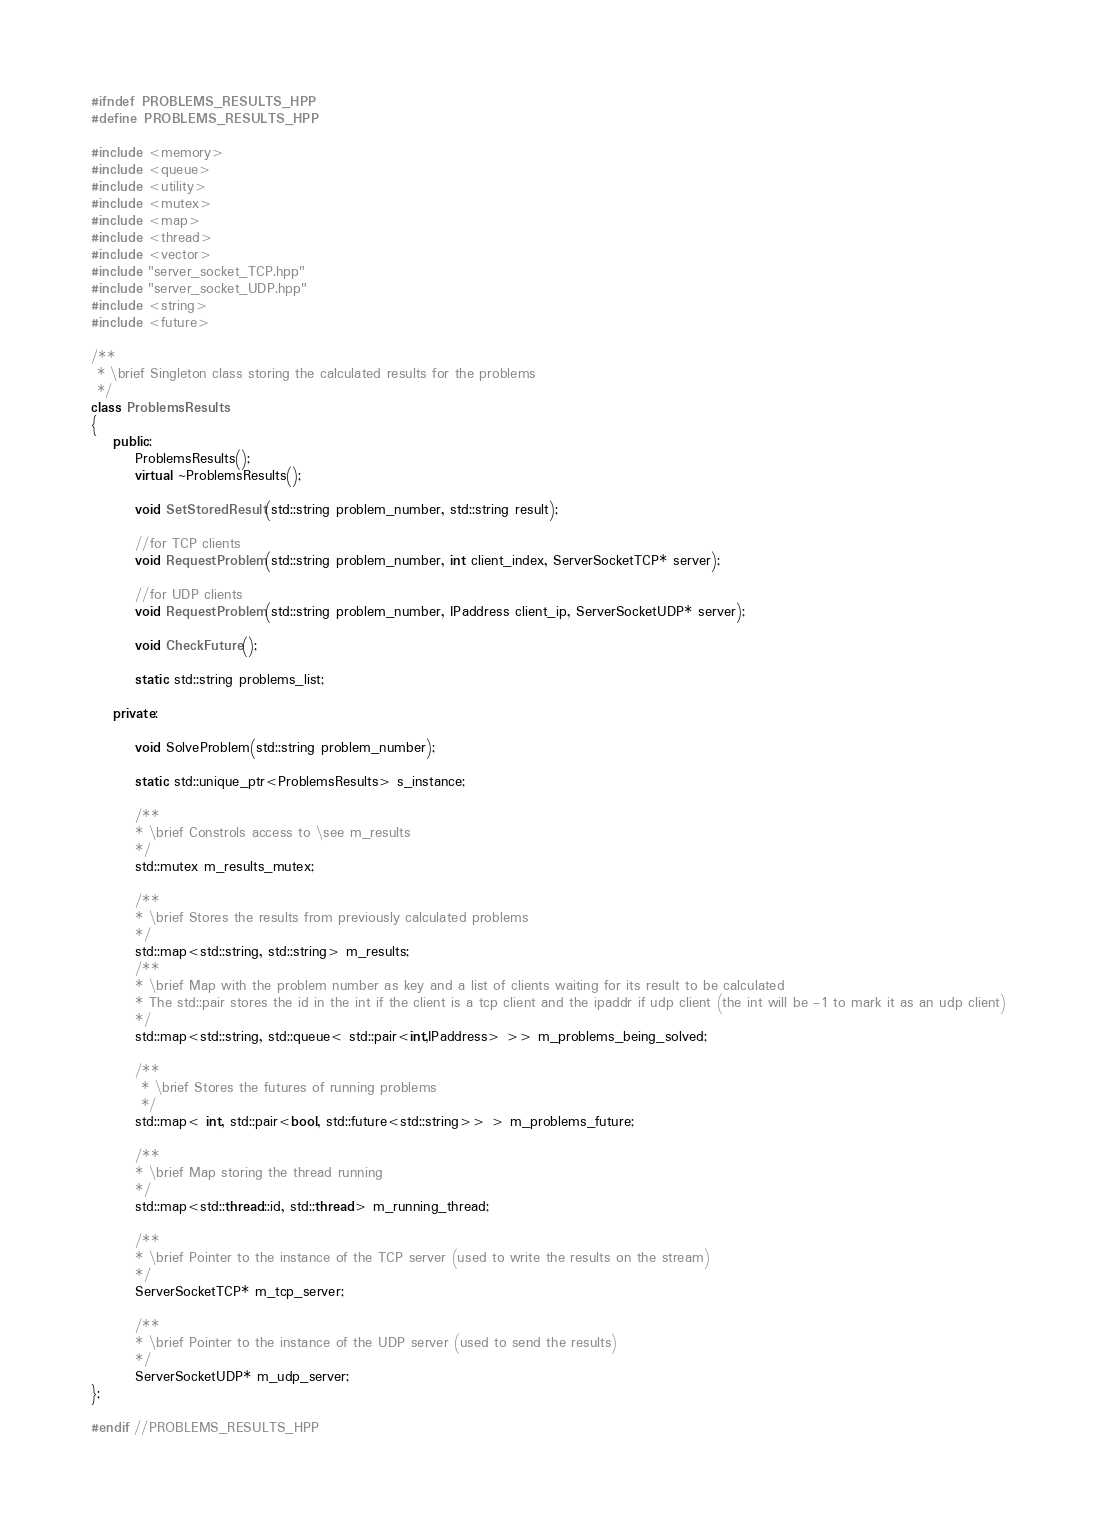<code> <loc_0><loc_0><loc_500><loc_500><_C++_>#ifndef PROBLEMS_RESULTS_HPP
#define PROBLEMS_RESULTS_HPP

#include <memory>
#include <queue>
#include <utility>
#include <mutex>
#include <map>
#include <thread>
#include <vector>
#include "server_socket_TCP.hpp"
#include "server_socket_UDP.hpp"
#include <string>
#include <future>

/**
 * \brief Singleton class storing the calculated results for the problems
 */
class ProblemsResults
{
    public:
        ProblemsResults();
        virtual ~ProblemsResults();

        void SetStoredResult(std::string problem_number, std::string result);

        //for TCP clients
        void RequestProblem(std::string problem_number, int client_index, ServerSocketTCP* server);

        //for UDP clients
        void RequestProblem(std::string problem_number, IPaddress client_ip, ServerSocketUDP* server);

        void CheckFuture();

        static std::string problems_list;

    private:

        void SolveProblem(std::string problem_number);

        static std::unique_ptr<ProblemsResults> s_instance;

        /**
        * \brief Constrols access to \see m_results
        */
        std::mutex m_results_mutex;

        /**
        * \brief Stores the results from previously calculated problems
        */
        std::map<std::string, std::string> m_results;
        /**
        * \brief Map with the problem number as key and a list of clients waiting for its result to be calculated
        * The std::pair stores the id in the int if the client is a tcp client and the ipaddr if udp client (the int will be -1 to mark it as an udp client)
        */
        std::map<std::string, std::queue< std::pair<int,IPaddress> >> m_problems_being_solved;

        /**
         * \brief Stores the futures of running problems
         */
        std::map< int, std::pair<bool, std::future<std::string>> > m_problems_future;

        /**
        * \brief Map storing the thread running
        */
        std::map<std::thread::id, std::thread> m_running_thread;

        /**
        * \brief Pointer to the instance of the TCP server (used to write the results on the stream)
        */
        ServerSocketTCP* m_tcp_server;

        /**
        * \brief Pointer to the instance of the UDP server (used to send the results)
        */
        ServerSocketUDP* m_udp_server;
};

#endif //PROBLEMS_RESULTS_HPP
</code> 